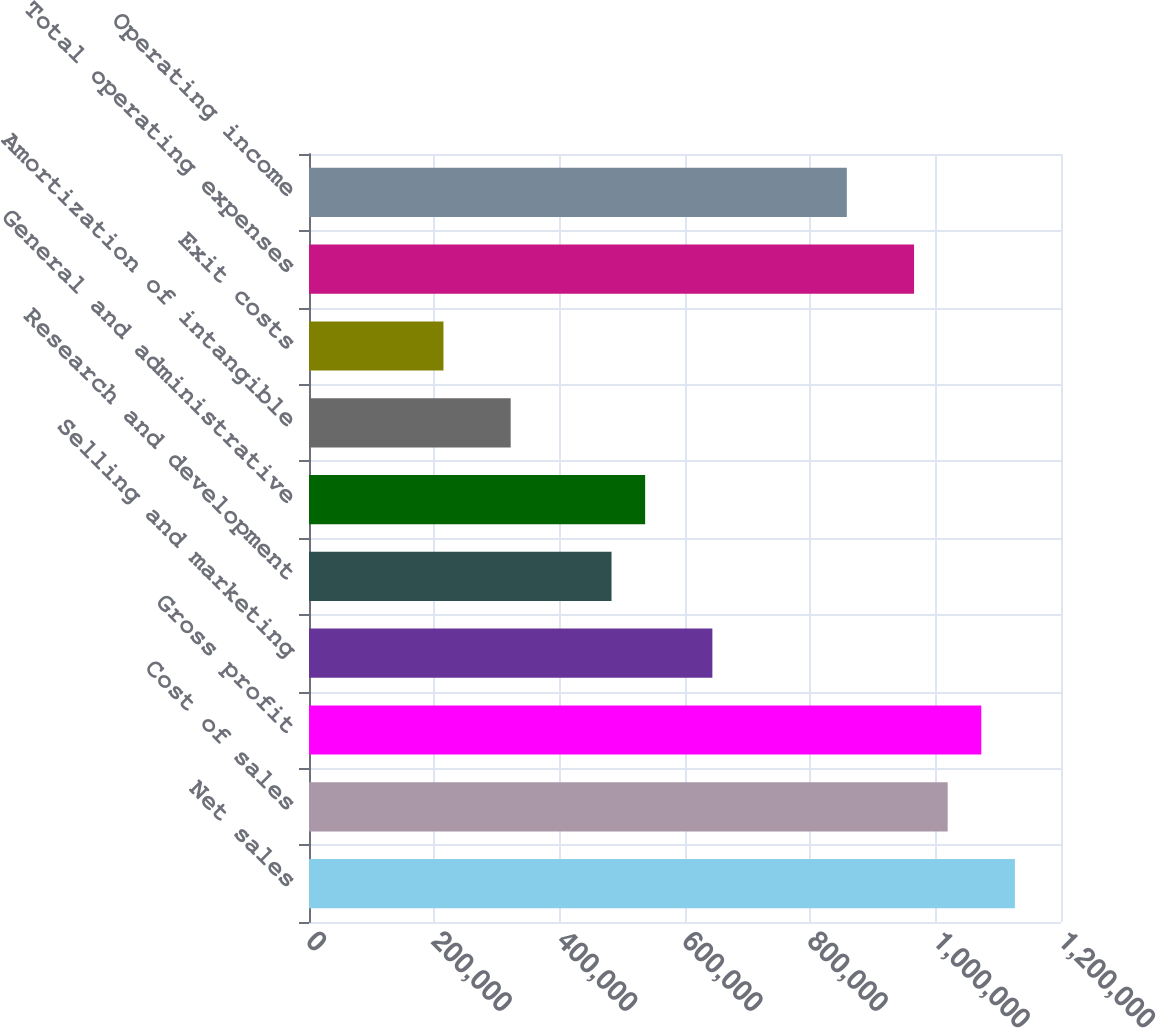Convert chart to OTSL. <chart><loc_0><loc_0><loc_500><loc_500><bar_chart><fcel>Net sales<fcel>Cost of sales<fcel>Gross profit<fcel>Selling and marketing<fcel>Research and development<fcel>General and administrative<fcel>Amortization of intangible<fcel>Exit costs<fcel>Total operating expenses<fcel>Operating income<nl><fcel>1.12643e+06<fcel>1.01915e+06<fcel>1.07279e+06<fcel>643676<fcel>482757<fcel>536397<fcel>321839<fcel>214560<fcel>965514<fcel>858234<nl></chart> 